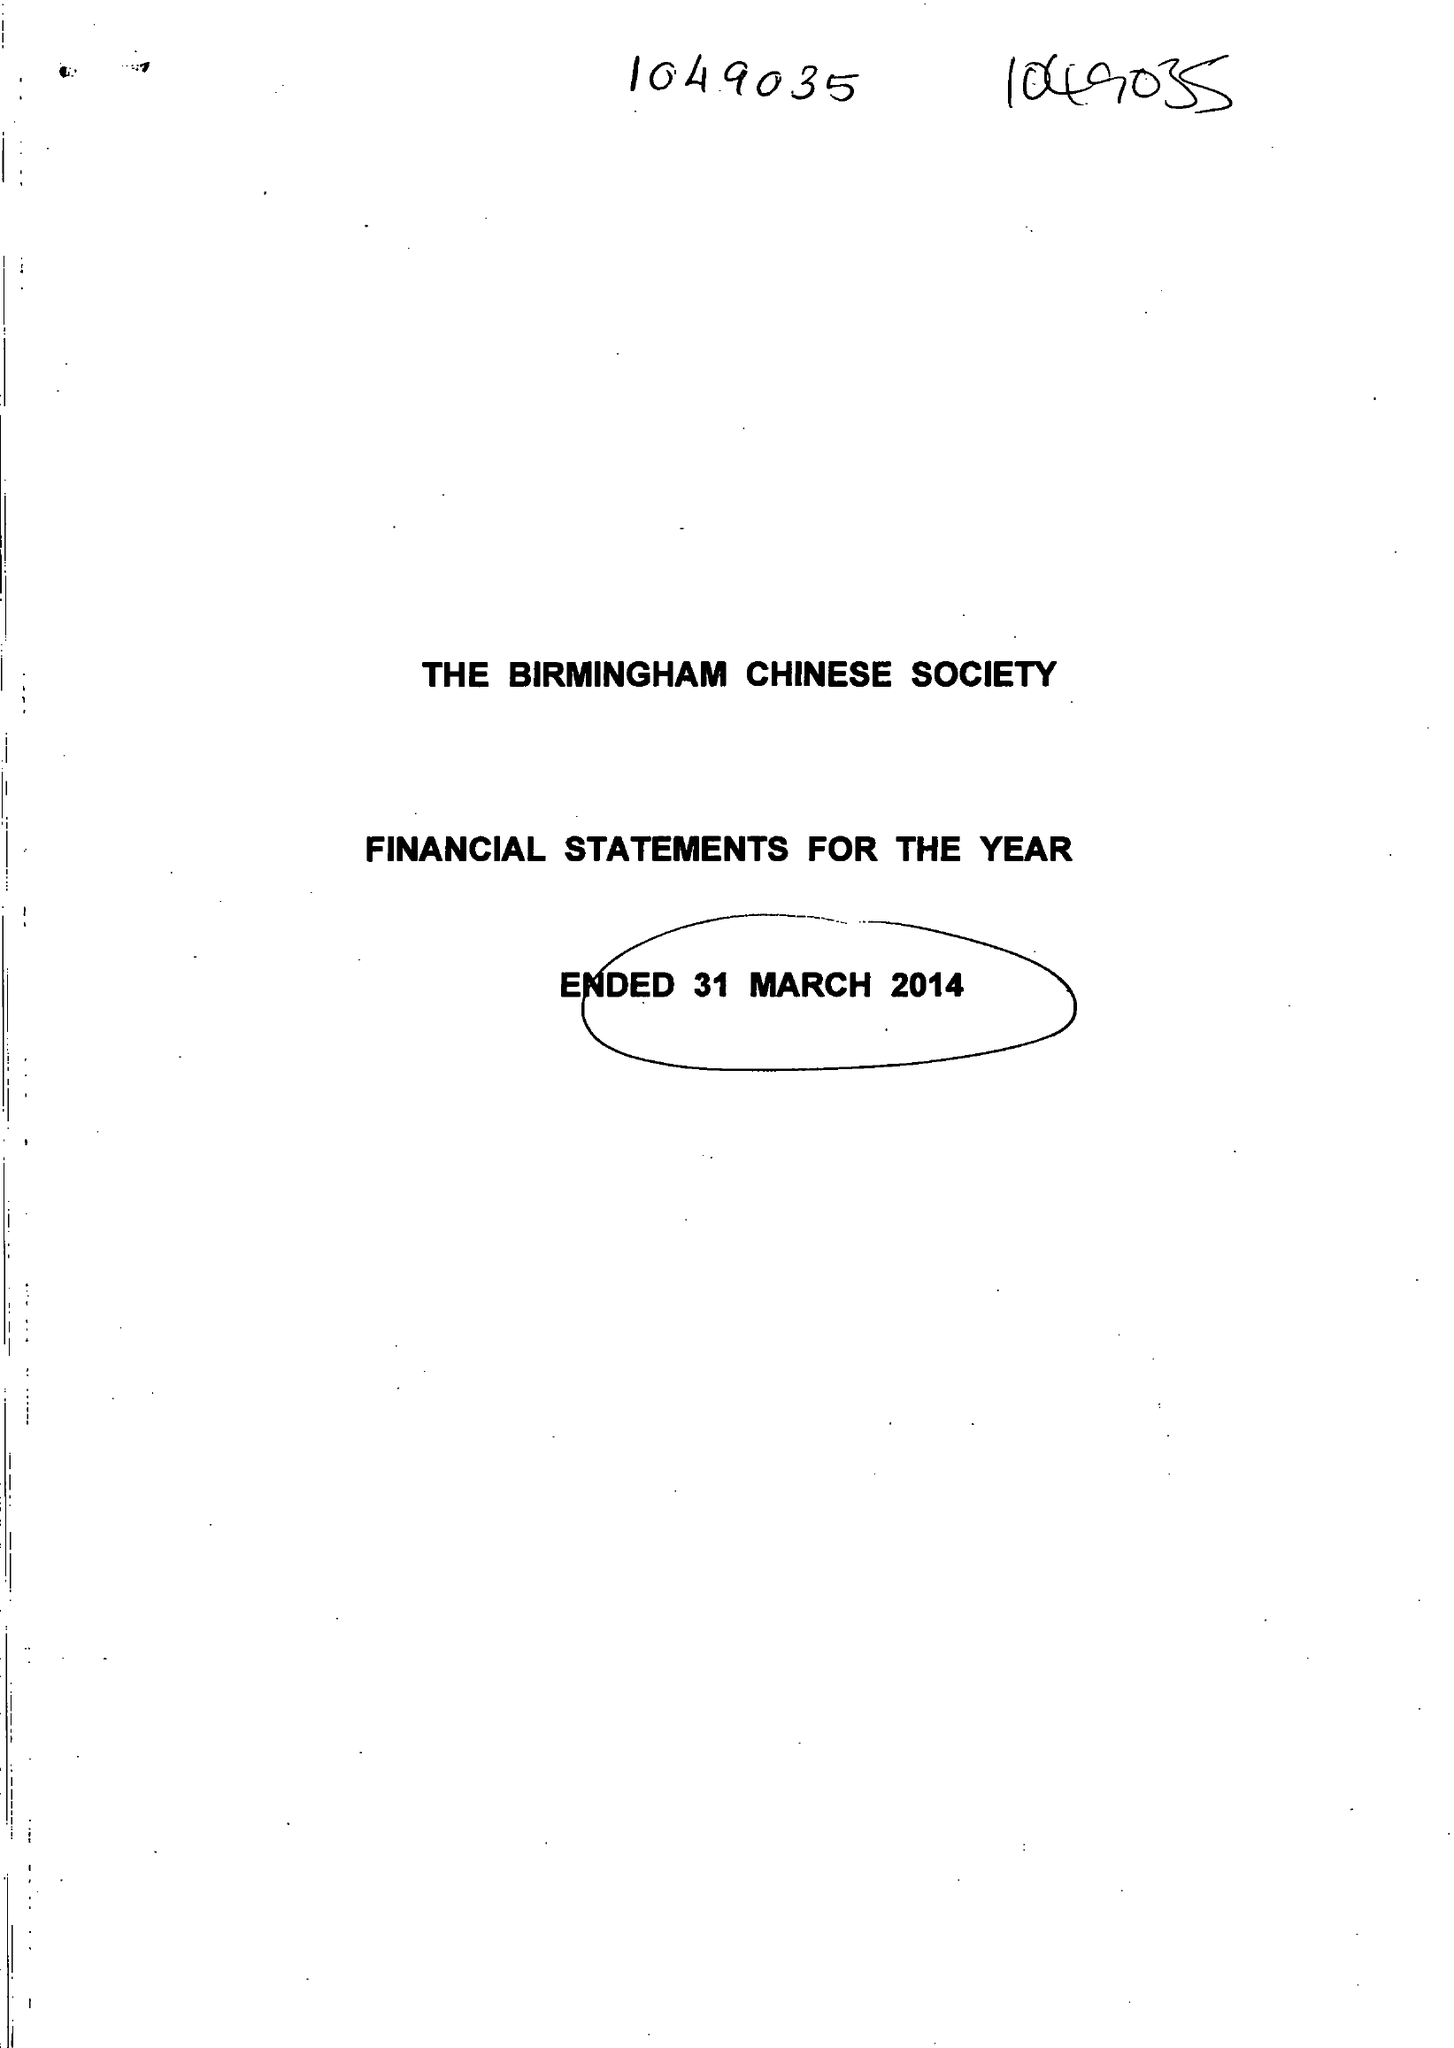What is the value for the income_annually_in_british_pounds?
Answer the question using a single word or phrase. 36010.00 